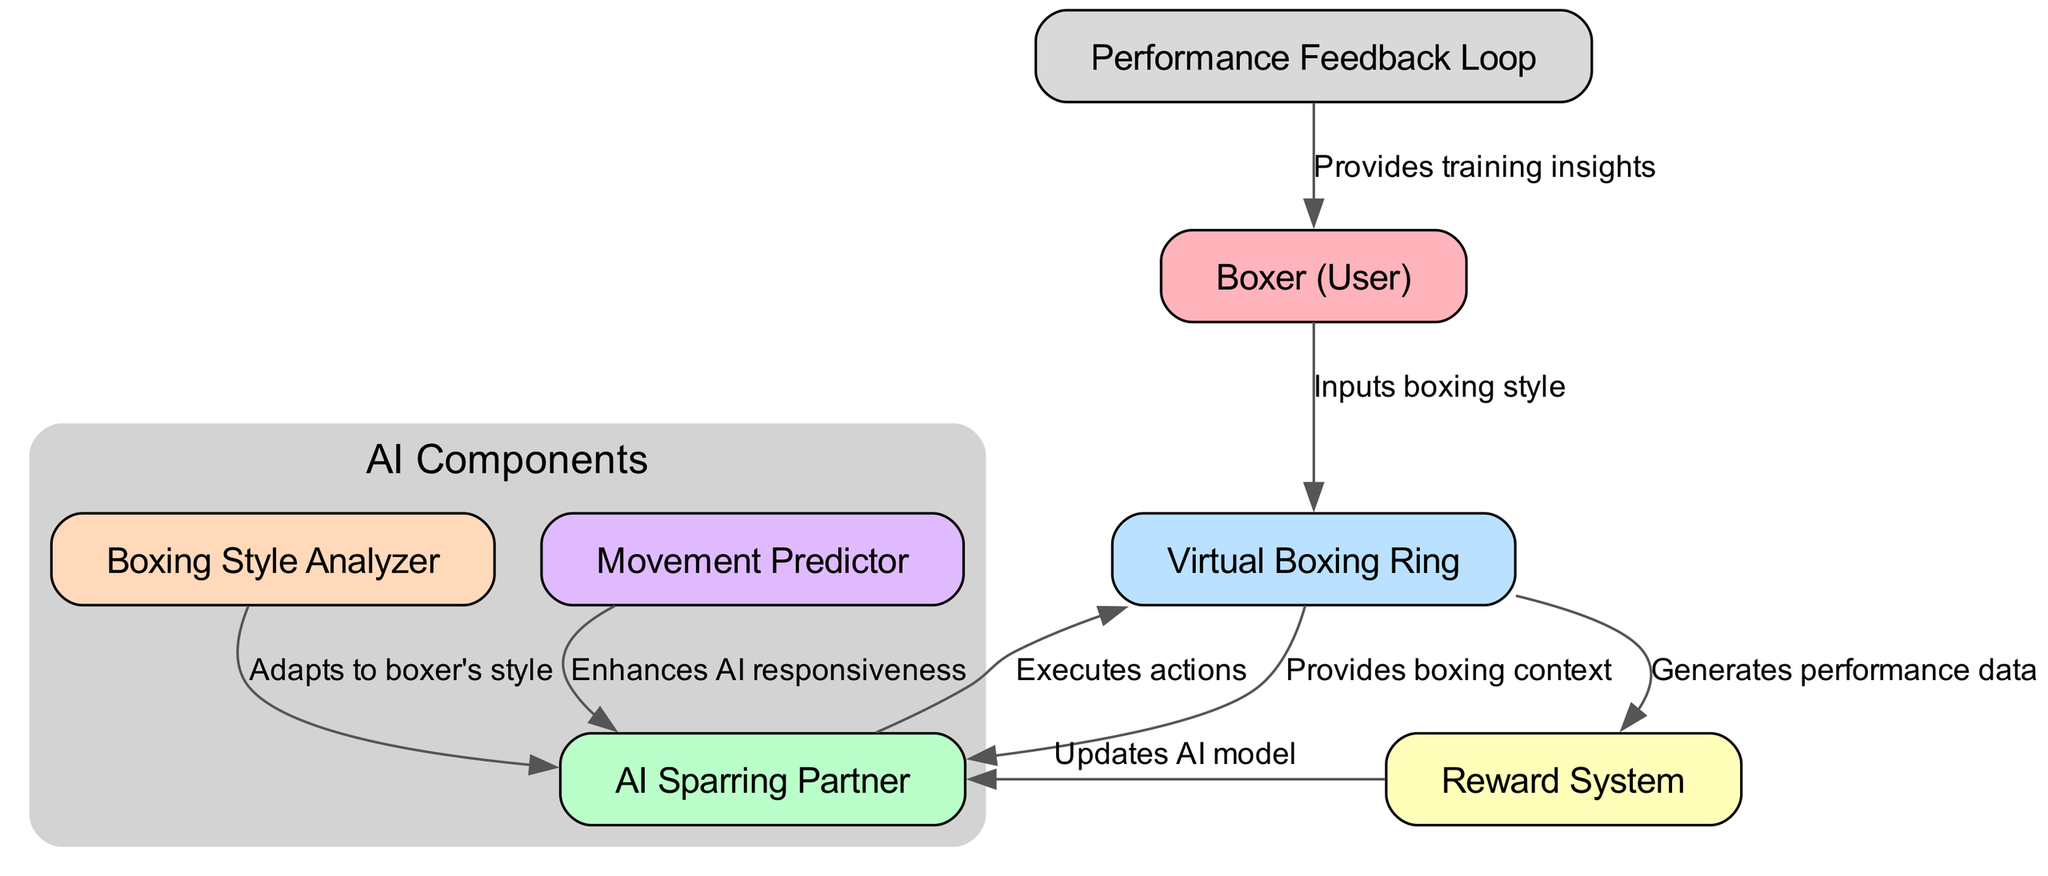What is the label of the node representing the human participant in the training process? The diagram labels the node representing the human participant as "Boxer (User)", which is clear from the node identification.
Answer: Boxer (User) How many nodes are present in the diagram? By counting all distinct nodes listed in the diagram, there are seven nodes: Boxer, AI Sparring Partner, Virtual Boxing Ring, Reward System, Boxing Style Analyzer, Movement Predictor, and Performance Feedback Loop.
Answer: Seven What action does the AI Sparring Partner perform towards the environment? The edge connecting the AI Sparring Partner to the environment describes the action taken as "Executes actions," indicating the AI's role in interacting with the boxing environment.
Answer: Executes actions Which component adapts the AI to the boxer's style? The Boxing Style Analyzer is specified as the component that adapts to the boxer's style, as indicated by the direct connection labeled "Adapts to boxer's style" leading to the AI Sparring Partner.
Answer: Boxing Style Analyzer What does the Reward System provide to the AI Sparring Partner? The edge from the Reward System to the AI Sparring Partner states that it "Updates AI model," which indicates the type of data or input the AI receives from the Reward System.
Answer: Updates AI model How does the environment feed information to the Reward System? The diagram shows that the environment generates performance data, which flows into the Reward System, indicating how performance metrics influence the AI's learning and improvement.
Answer: Generates performance data What feedback does the Performance Feedback Loop provide? The Performance Feedback Loop sends "Provides training insights" back to the boxer, implying it offers valuable information on the boxer's performance and effectiveness in training.
Answer: Provides training insights Which node enhances the AI’s responsiveness? The movement predictor is the specific node that is identified as enhancing the AI's responsiveness, as stated in the connection labeled "Enhances AI responsiveness" directed towards the AI Sparring Partner.
Answer: Movement Predictor How many edges are there in the diagram? The total number of edges can be counted from the connections depicted, resulting in eight edges that connect the nodes, indicating the relationships and flow of information within the diagram.
Answer: Eight 